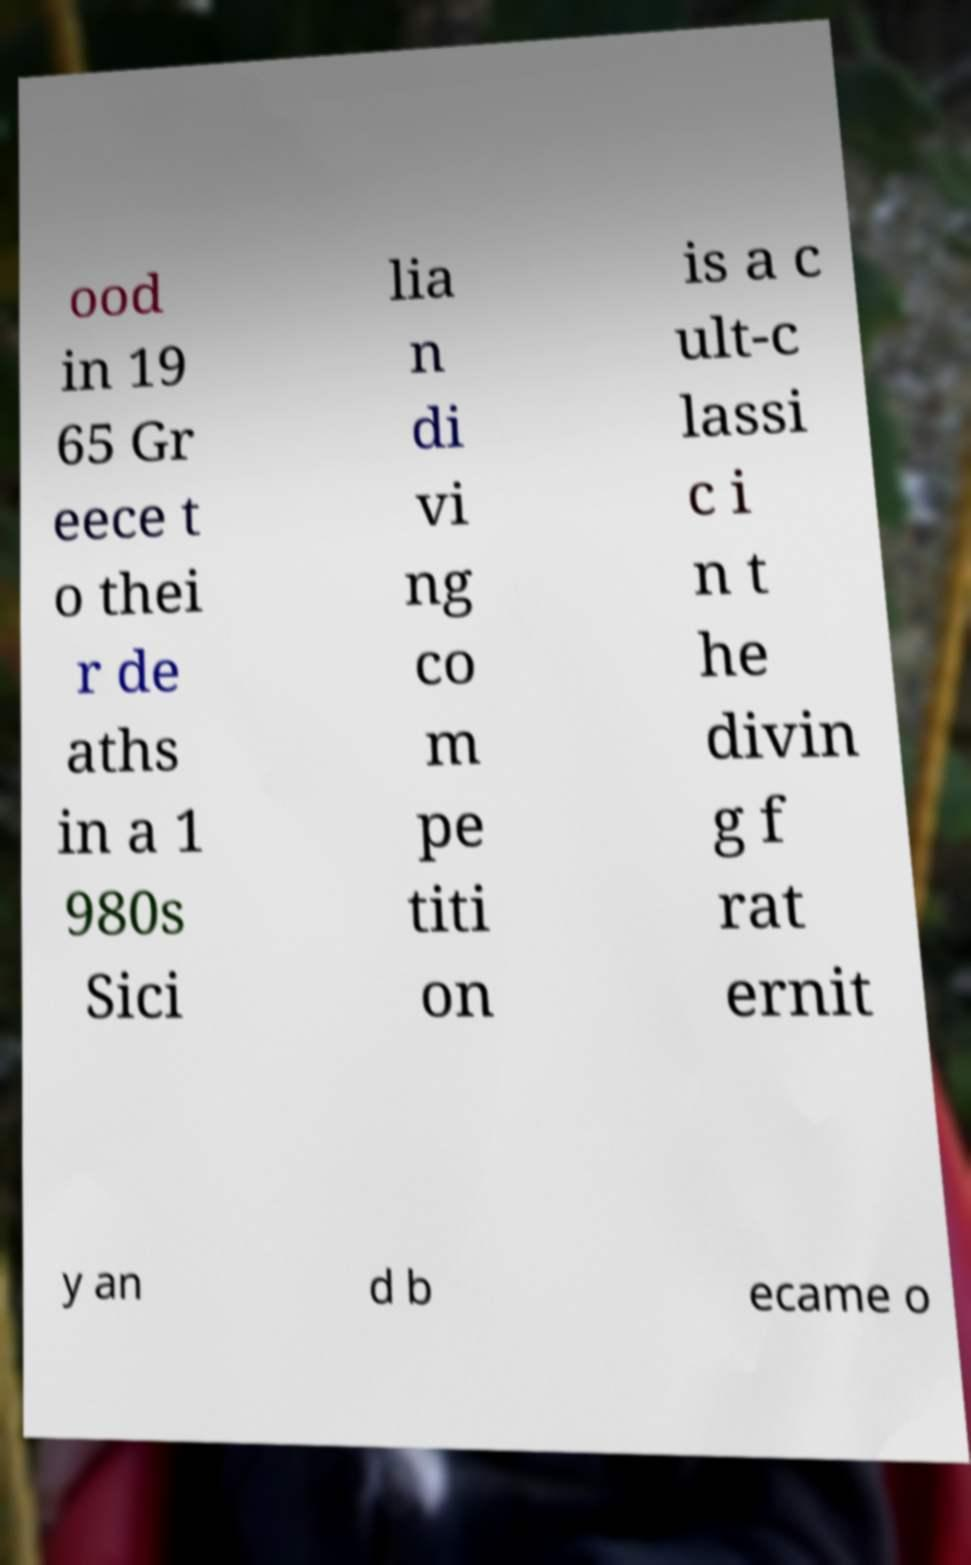I need the written content from this picture converted into text. Can you do that? ood in 19 65 Gr eece t o thei r de aths in a 1 980s Sici lia n di vi ng co m pe titi on is a c ult-c lassi c i n t he divin g f rat ernit y an d b ecame o 